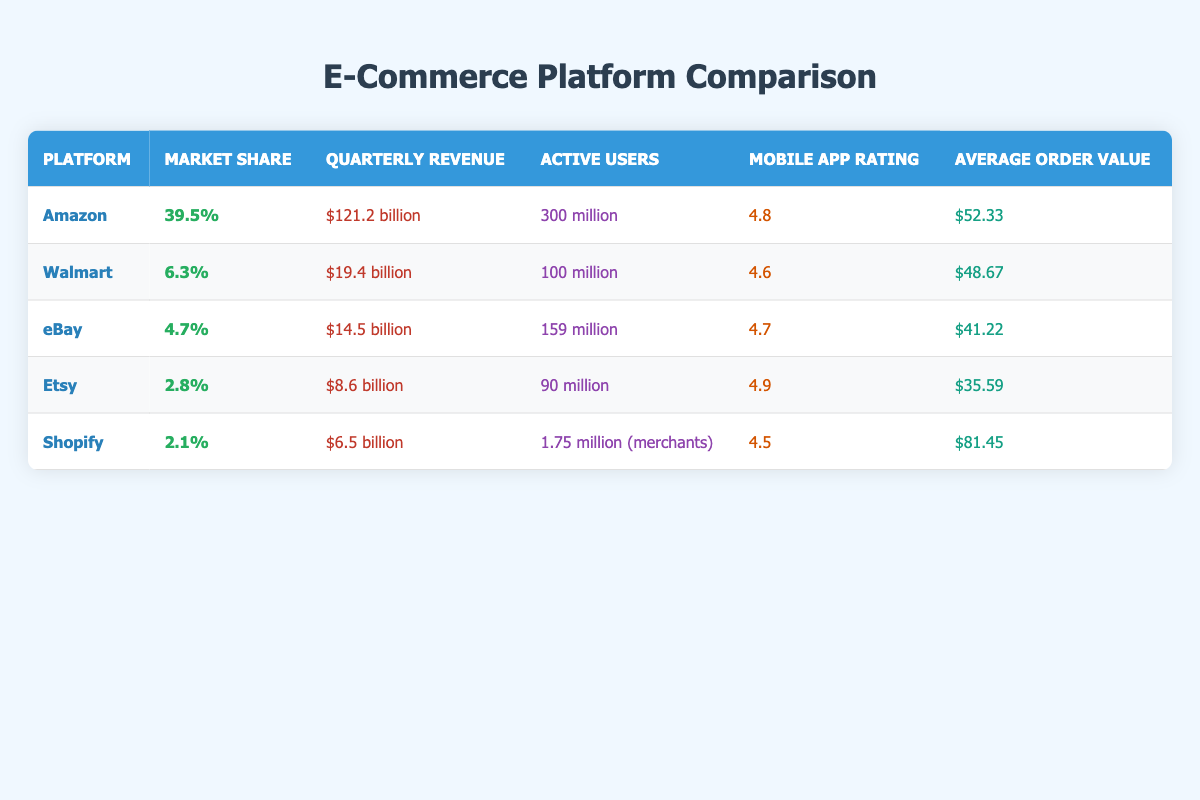What is the market share of Amazon? According to the table, Amazon's market share is listed as 39.5%.
Answer: 39.5% How many active users does eBay have? The table shows that eBay has 159 million active users.
Answer: 159 million Which platform has the highest mobile app rating? From the table, Etsy has the highest mobile app rating at 4.9.
Answer: 4.9 What is the average order value for Shopify? The table indicates that Shopify's average order value is $81.45.
Answer: $81.45 What is the total quarterly revenue of Walmart and eBay combined? To find the total revenue, we add Walmart's quarterly revenue of $19.4 billion and eBay's $14.5 billion: 19.4 + 14.5 = 33.9 billion.
Answer: $33.9 billion Is it true that Etsy has a higher market share than Shopify? Comparing the market shares, Etsy has 2.8% and Shopify has 2.1%, so it is true that Etsy has a higher market share.
Answer: Yes Which platform has the lowest average order value, and what is that value? The table shows that Etsy has the lowest average order value at $35.59.
Answer: $35.59 If we look at all platforms, what is the average market share? To calculate the average market share, we sum up the market shares: 39.5 + 6.3 + 4.7 + 2.8 + 2.1 = 55.4%. There are 5 platforms, so we divide: 55.4/5 = 11.08%.
Answer: 11.08% Did any platform have over 300 million active users? By examining the table, we see that only Amazon has 300 million active users, confirming that one platform does indeed exceed 300 million.
Answer: Yes What is the difference in active users between Walmart and Shopify? Walmart has 100 million active users, while Shopify has 1.75 million. The difference is 100 million - 1.75 million = 98.25 million.
Answer: 98.25 million 